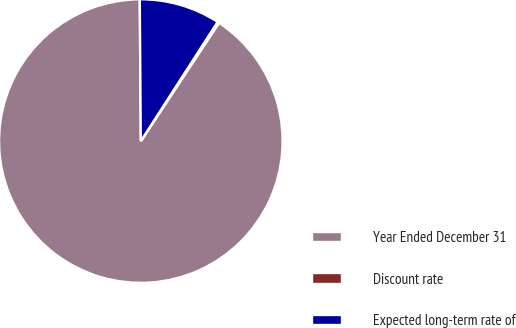Convert chart. <chart><loc_0><loc_0><loc_500><loc_500><pie_chart><fcel>Year Ended December 31<fcel>Discount rate<fcel>Expected long-term rate of<nl><fcel>90.58%<fcel>0.19%<fcel>9.23%<nl></chart> 